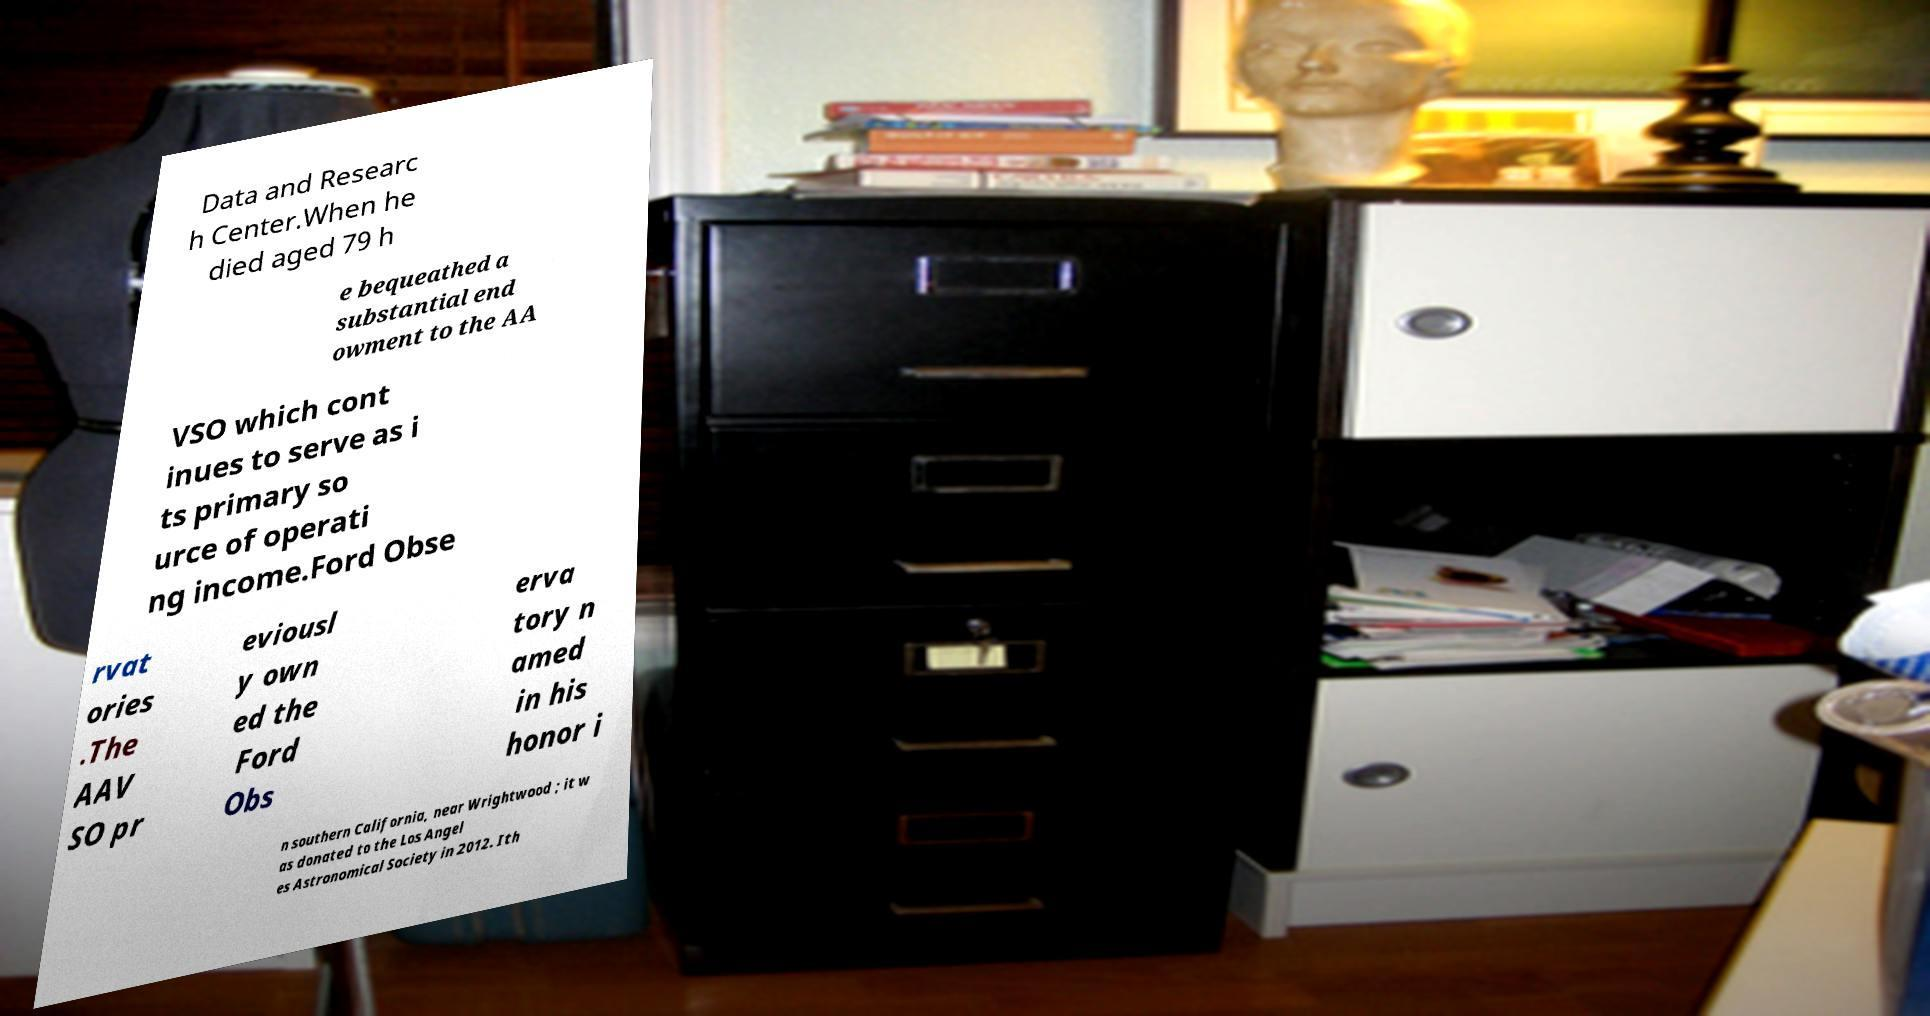Can you read and provide the text displayed in the image?This photo seems to have some interesting text. Can you extract and type it out for me? Data and Researc h Center.When he died aged 79 h e bequeathed a substantial end owment to the AA VSO which cont inues to serve as i ts primary so urce of operati ng income.Ford Obse rvat ories .The AAV SO pr eviousl y own ed the Ford Obs erva tory n amed in his honor i n southern California, near Wrightwood ; it w as donated to the Los Angel es Astronomical Society in 2012. Ith 